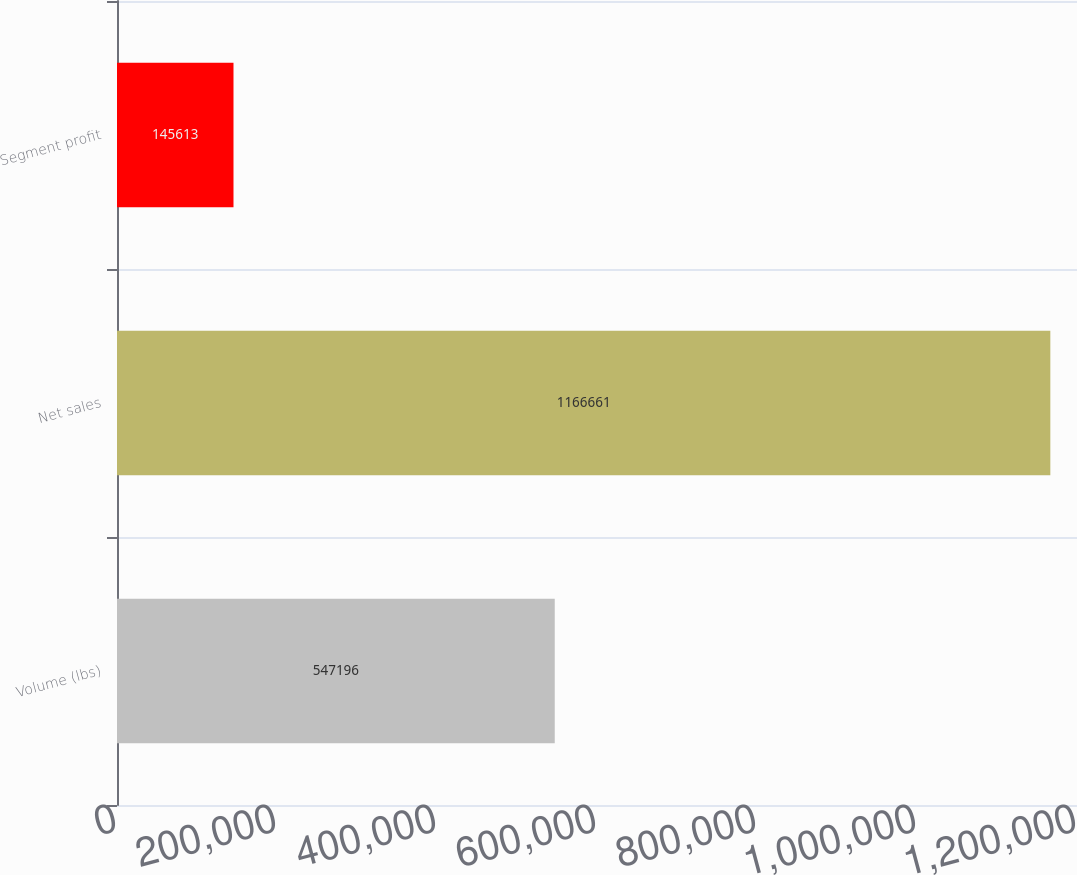Convert chart to OTSL. <chart><loc_0><loc_0><loc_500><loc_500><bar_chart><fcel>Volume (lbs)<fcel>Net sales<fcel>Segment profit<nl><fcel>547196<fcel>1.16666e+06<fcel>145613<nl></chart> 